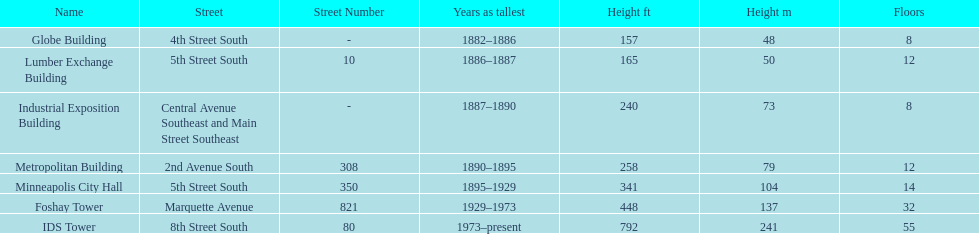Give me the full table as a dictionary. {'header': ['Name', 'Street', 'Street Number', 'Years as tallest', 'Height ft', 'Height m', 'Floors'], 'rows': [['Globe Building', '4th Street South', '-', '1882–1886', '157', '48', '8'], ['Lumber Exchange Building', '5th Street South', '10', '1886–1887', '165', '50', '12'], ['Industrial Exposition Building', 'Central Avenue Southeast and Main Street Southeast', '-', '1887–1890', '240', '73', '8'], ['Metropolitan Building', '2nd Avenue South', '308', '1890–1895', '258', '79', '12'], ['Minneapolis City Hall', '5th Street South', '350', '1895–1929', '341', '104', '14'], ['Foshay Tower', 'Marquette Avenue', '821', '1929–1973', '448', '137', '32'], ['IDS Tower', '8th Street South', '80', '1973–present', '792', '241', '55']]} Which building has the same number of floors as the lumber exchange building? Metropolitan Building. 